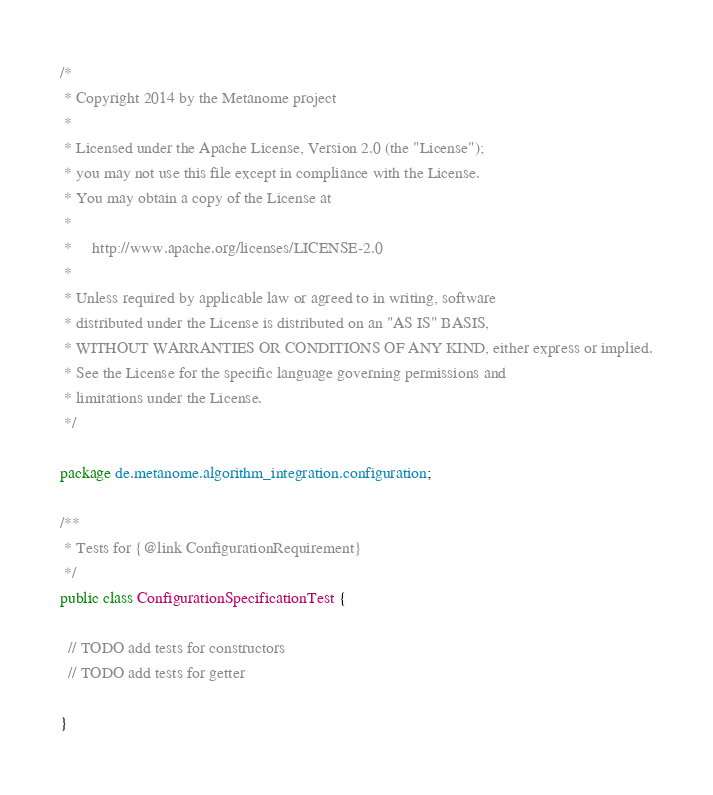Convert code to text. <code><loc_0><loc_0><loc_500><loc_500><_Java_>/*
 * Copyright 2014 by the Metanome project
 *
 * Licensed under the Apache License, Version 2.0 (the "License");
 * you may not use this file except in compliance with the License.
 * You may obtain a copy of the License at
 *
 *     http://www.apache.org/licenses/LICENSE-2.0
 *
 * Unless required by applicable law or agreed to in writing, software
 * distributed under the License is distributed on an "AS IS" BASIS,
 * WITHOUT WARRANTIES OR CONDITIONS OF ANY KIND, either express or implied.
 * See the License for the specific language governing permissions and
 * limitations under the License.
 */

package de.metanome.algorithm_integration.configuration;

/**
 * Tests for {@link ConfigurationRequirement}
 */
public class ConfigurationSpecificationTest {

  // TODO add tests for constructors
  // TODO add tests for getter

}
</code> 